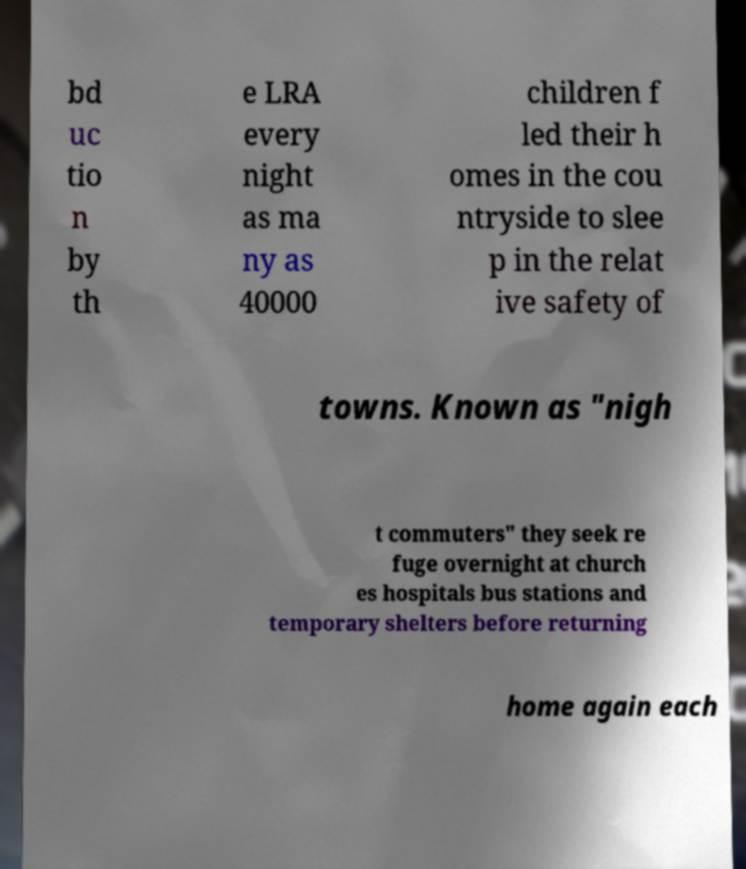I need the written content from this picture converted into text. Can you do that? bd uc tio n by th e LRA every night as ma ny as 40000 children f led their h omes in the cou ntryside to slee p in the relat ive safety of towns. Known as "nigh t commuters" they seek re fuge overnight at church es hospitals bus stations and temporary shelters before returning home again each 